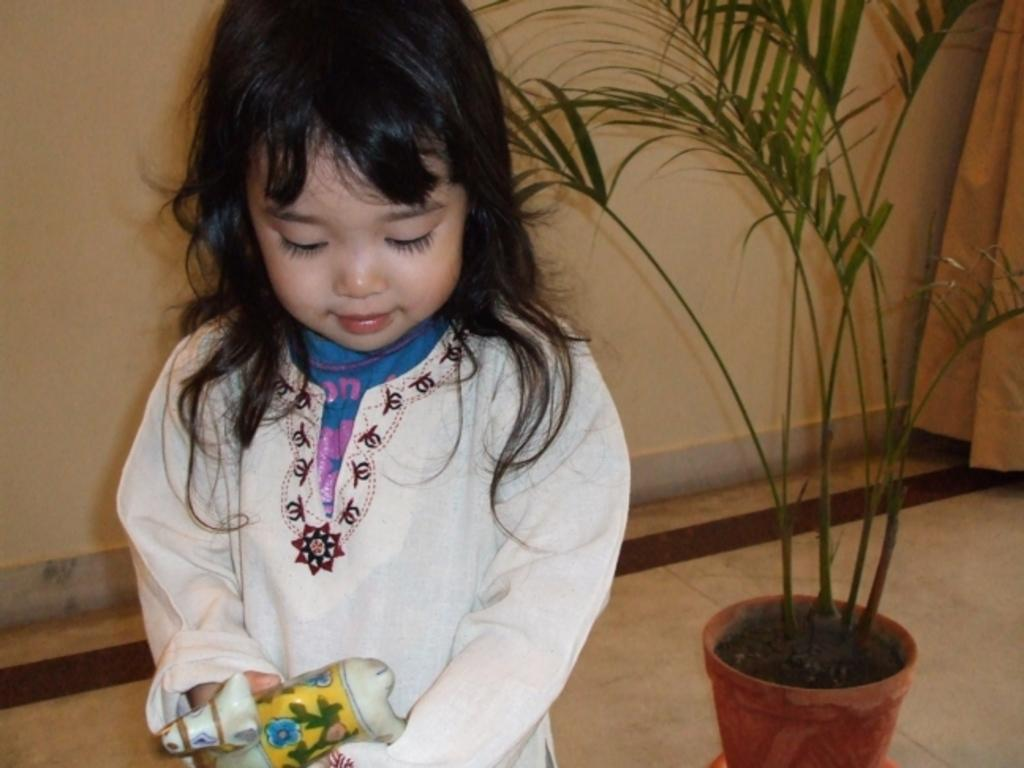Who is present in the image? There is a girl in the image. What can be seen in the background of the image? There is a plant, a floor, a curtain, and a wall visible in the image. What is the girl holding in the image? The girl is holding an object. What type of page can be seen turning in the image? There is no page present in the image, and therefore no such activity can be observed. 